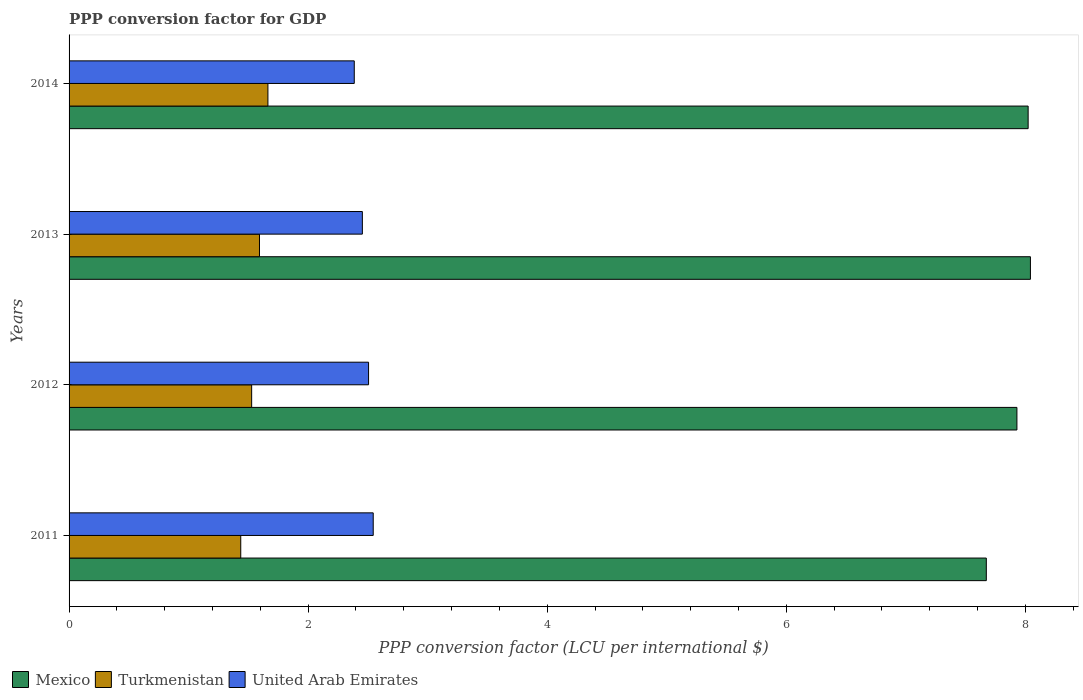How many different coloured bars are there?
Your response must be concise. 3. Are the number of bars on each tick of the Y-axis equal?
Give a very brief answer. Yes. How many bars are there on the 4th tick from the top?
Give a very brief answer. 3. What is the PPP conversion factor for GDP in Turkmenistan in 2012?
Provide a short and direct response. 1.53. Across all years, what is the maximum PPP conversion factor for GDP in Turkmenistan?
Provide a short and direct response. 1.66. Across all years, what is the minimum PPP conversion factor for GDP in United Arab Emirates?
Keep it short and to the point. 2.39. In which year was the PPP conversion factor for GDP in Turkmenistan minimum?
Make the answer very short. 2011. What is the total PPP conversion factor for GDP in Mexico in the graph?
Your response must be concise. 31.67. What is the difference between the PPP conversion factor for GDP in Mexico in 2012 and that in 2014?
Offer a terse response. -0.09. What is the difference between the PPP conversion factor for GDP in Turkmenistan in 2011 and the PPP conversion factor for GDP in Mexico in 2012?
Your response must be concise. -6.49. What is the average PPP conversion factor for GDP in United Arab Emirates per year?
Provide a succinct answer. 2.47. In the year 2013, what is the difference between the PPP conversion factor for GDP in Mexico and PPP conversion factor for GDP in Turkmenistan?
Give a very brief answer. 6.45. In how many years, is the PPP conversion factor for GDP in United Arab Emirates greater than 2 LCU?
Your answer should be very brief. 4. What is the ratio of the PPP conversion factor for GDP in United Arab Emirates in 2011 to that in 2014?
Keep it short and to the point. 1.07. What is the difference between the highest and the second highest PPP conversion factor for GDP in Mexico?
Your answer should be compact. 0.02. What is the difference between the highest and the lowest PPP conversion factor for GDP in United Arab Emirates?
Your answer should be very brief. 0.16. In how many years, is the PPP conversion factor for GDP in United Arab Emirates greater than the average PPP conversion factor for GDP in United Arab Emirates taken over all years?
Provide a succinct answer. 2. What does the 1st bar from the top in 2014 represents?
Keep it short and to the point. United Arab Emirates. What does the 1st bar from the bottom in 2013 represents?
Your answer should be compact. Mexico. How many bars are there?
Provide a succinct answer. 12. How many years are there in the graph?
Ensure brevity in your answer.  4. Are the values on the major ticks of X-axis written in scientific E-notation?
Your response must be concise. No. Does the graph contain any zero values?
Offer a terse response. No. Does the graph contain grids?
Make the answer very short. No. Where does the legend appear in the graph?
Your answer should be compact. Bottom left. How many legend labels are there?
Provide a succinct answer. 3. What is the title of the graph?
Provide a succinct answer. PPP conversion factor for GDP. What is the label or title of the X-axis?
Your answer should be very brief. PPP conversion factor (LCU per international $). What is the PPP conversion factor (LCU per international $) in Mexico in 2011?
Make the answer very short. 7.67. What is the PPP conversion factor (LCU per international $) of Turkmenistan in 2011?
Provide a succinct answer. 1.44. What is the PPP conversion factor (LCU per international $) in United Arab Emirates in 2011?
Provide a succinct answer. 2.54. What is the PPP conversion factor (LCU per international $) of Mexico in 2012?
Provide a short and direct response. 7.93. What is the PPP conversion factor (LCU per international $) in Turkmenistan in 2012?
Give a very brief answer. 1.53. What is the PPP conversion factor (LCU per international $) of United Arab Emirates in 2012?
Provide a short and direct response. 2.51. What is the PPP conversion factor (LCU per international $) of Mexico in 2013?
Keep it short and to the point. 8.04. What is the PPP conversion factor (LCU per international $) in Turkmenistan in 2013?
Your answer should be very brief. 1.59. What is the PPP conversion factor (LCU per international $) of United Arab Emirates in 2013?
Your response must be concise. 2.45. What is the PPP conversion factor (LCU per international $) in Mexico in 2014?
Give a very brief answer. 8.02. What is the PPP conversion factor (LCU per international $) in Turkmenistan in 2014?
Your answer should be very brief. 1.66. What is the PPP conversion factor (LCU per international $) of United Arab Emirates in 2014?
Provide a short and direct response. 2.39. Across all years, what is the maximum PPP conversion factor (LCU per international $) in Mexico?
Keep it short and to the point. 8.04. Across all years, what is the maximum PPP conversion factor (LCU per international $) in Turkmenistan?
Your answer should be very brief. 1.66. Across all years, what is the maximum PPP conversion factor (LCU per international $) of United Arab Emirates?
Offer a terse response. 2.54. Across all years, what is the minimum PPP conversion factor (LCU per international $) in Mexico?
Ensure brevity in your answer.  7.67. Across all years, what is the minimum PPP conversion factor (LCU per international $) of Turkmenistan?
Provide a short and direct response. 1.44. Across all years, what is the minimum PPP conversion factor (LCU per international $) in United Arab Emirates?
Your answer should be compact. 2.39. What is the total PPP conversion factor (LCU per international $) in Mexico in the graph?
Your response must be concise. 31.67. What is the total PPP conversion factor (LCU per international $) of Turkmenistan in the graph?
Keep it short and to the point. 6.22. What is the total PPP conversion factor (LCU per international $) of United Arab Emirates in the graph?
Your answer should be very brief. 9.89. What is the difference between the PPP conversion factor (LCU per international $) of Mexico in 2011 and that in 2012?
Provide a short and direct response. -0.26. What is the difference between the PPP conversion factor (LCU per international $) in Turkmenistan in 2011 and that in 2012?
Your response must be concise. -0.09. What is the difference between the PPP conversion factor (LCU per international $) in United Arab Emirates in 2011 and that in 2012?
Give a very brief answer. 0.04. What is the difference between the PPP conversion factor (LCU per international $) of Mexico in 2011 and that in 2013?
Keep it short and to the point. -0.37. What is the difference between the PPP conversion factor (LCU per international $) in Turkmenistan in 2011 and that in 2013?
Give a very brief answer. -0.16. What is the difference between the PPP conversion factor (LCU per international $) in United Arab Emirates in 2011 and that in 2013?
Your answer should be very brief. 0.09. What is the difference between the PPP conversion factor (LCU per international $) in Mexico in 2011 and that in 2014?
Your answer should be very brief. -0.35. What is the difference between the PPP conversion factor (LCU per international $) of Turkmenistan in 2011 and that in 2014?
Give a very brief answer. -0.23. What is the difference between the PPP conversion factor (LCU per international $) in United Arab Emirates in 2011 and that in 2014?
Keep it short and to the point. 0.16. What is the difference between the PPP conversion factor (LCU per international $) of Mexico in 2012 and that in 2013?
Ensure brevity in your answer.  -0.11. What is the difference between the PPP conversion factor (LCU per international $) in Turkmenistan in 2012 and that in 2013?
Provide a short and direct response. -0.07. What is the difference between the PPP conversion factor (LCU per international $) of United Arab Emirates in 2012 and that in 2013?
Give a very brief answer. 0.05. What is the difference between the PPP conversion factor (LCU per international $) in Mexico in 2012 and that in 2014?
Your answer should be compact. -0.09. What is the difference between the PPP conversion factor (LCU per international $) in Turkmenistan in 2012 and that in 2014?
Your answer should be compact. -0.14. What is the difference between the PPP conversion factor (LCU per international $) of United Arab Emirates in 2012 and that in 2014?
Your response must be concise. 0.12. What is the difference between the PPP conversion factor (LCU per international $) in Mexico in 2013 and that in 2014?
Give a very brief answer. 0.02. What is the difference between the PPP conversion factor (LCU per international $) of Turkmenistan in 2013 and that in 2014?
Give a very brief answer. -0.07. What is the difference between the PPP conversion factor (LCU per international $) of United Arab Emirates in 2013 and that in 2014?
Your answer should be very brief. 0.07. What is the difference between the PPP conversion factor (LCU per international $) in Mexico in 2011 and the PPP conversion factor (LCU per international $) in Turkmenistan in 2012?
Your answer should be compact. 6.15. What is the difference between the PPP conversion factor (LCU per international $) in Mexico in 2011 and the PPP conversion factor (LCU per international $) in United Arab Emirates in 2012?
Your response must be concise. 5.17. What is the difference between the PPP conversion factor (LCU per international $) in Turkmenistan in 2011 and the PPP conversion factor (LCU per international $) in United Arab Emirates in 2012?
Give a very brief answer. -1.07. What is the difference between the PPP conversion factor (LCU per international $) of Mexico in 2011 and the PPP conversion factor (LCU per international $) of Turkmenistan in 2013?
Your answer should be very brief. 6.08. What is the difference between the PPP conversion factor (LCU per international $) of Mexico in 2011 and the PPP conversion factor (LCU per international $) of United Arab Emirates in 2013?
Give a very brief answer. 5.22. What is the difference between the PPP conversion factor (LCU per international $) of Turkmenistan in 2011 and the PPP conversion factor (LCU per international $) of United Arab Emirates in 2013?
Your response must be concise. -1.02. What is the difference between the PPP conversion factor (LCU per international $) of Mexico in 2011 and the PPP conversion factor (LCU per international $) of Turkmenistan in 2014?
Your response must be concise. 6.01. What is the difference between the PPP conversion factor (LCU per international $) of Mexico in 2011 and the PPP conversion factor (LCU per international $) of United Arab Emirates in 2014?
Your response must be concise. 5.29. What is the difference between the PPP conversion factor (LCU per international $) of Turkmenistan in 2011 and the PPP conversion factor (LCU per international $) of United Arab Emirates in 2014?
Your response must be concise. -0.95. What is the difference between the PPP conversion factor (LCU per international $) of Mexico in 2012 and the PPP conversion factor (LCU per international $) of Turkmenistan in 2013?
Ensure brevity in your answer.  6.34. What is the difference between the PPP conversion factor (LCU per international $) in Mexico in 2012 and the PPP conversion factor (LCU per international $) in United Arab Emirates in 2013?
Offer a very short reply. 5.48. What is the difference between the PPP conversion factor (LCU per international $) in Turkmenistan in 2012 and the PPP conversion factor (LCU per international $) in United Arab Emirates in 2013?
Give a very brief answer. -0.93. What is the difference between the PPP conversion factor (LCU per international $) in Mexico in 2012 and the PPP conversion factor (LCU per international $) in Turkmenistan in 2014?
Provide a succinct answer. 6.27. What is the difference between the PPP conversion factor (LCU per international $) of Mexico in 2012 and the PPP conversion factor (LCU per international $) of United Arab Emirates in 2014?
Provide a succinct answer. 5.54. What is the difference between the PPP conversion factor (LCU per international $) in Turkmenistan in 2012 and the PPP conversion factor (LCU per international $) in United Arab Emirates in 2014?
Offer a very short reply. -0.86. What is the difference between the PPP conversion factor (LCU per international $) of Mexico in 2013 and the PPP conversion factor (LCU per international $) of Turkmenistan in 2014?
Give a very brief answer. 6.38. What is the difference between the PPP conversion factor (LCU per international $) of Mexico in 2013 and the PPP conversion factor (LCU per international $) of United Arab Emirates in 2014?
Give a very brief answer. 5.66. What is the difference between the PPP conversion factor (LCU per international $) of Turkmenistan in 2013 and the PPP conversion factor (LCU per international $) of United Arab Emirates in 2014?
Offer a very short reply. -0.79. What is the average PPP conversion factor (LCU per international $) in Mexico per year?
Your answer should be compact. 7.92. What is the average PPP conversion factor (LCU per international $) of Turkmenistan per year?
Give a very brief answer. 1.55. What is the average PPP conversion factor (LCU per international $) of United Arab Emirates per year?
Your answer should be compact. 2.47. In the year 2011, what is the difference between the PPP conversion factor (LCU per international $) in Mexico and PPP conversion factor (LCU per international $) in Turkmenistan?
Make the answer very short. 6.24. In the year 2011, what is the difference between the PPP conversion factor (LCU per international $) in Mexico and PPP conversion factor (LCU per international $) in United Arab Emirates?
Offer a very short reply. 5.13. In the year 2011, what is the difference between the PPP conversion factor (LCU per international $) of Turkmenistan and PPP conversion factor (LCU per international $) of United Arab Emirates?
Ensure brevity in your answer.  -1.11. In the year 2012, what is the difference between the PPP conversion factor (LCU per international $) of Mexico and PPP conversion factor (LCU per international $) of Turkmenistan?
Offer a terse response. 6.4. In the year 2012, what is the difference between the PPP conversion factor (LCU per international $) of Mexico and PPP conversion factor (LCU per international $) of United Arab Emirates?
Keep it short and to the point. 5.42. In the year 2012, what is the difference between the PPP conversion factor (LCU per international $) of Turkmenistan and PPP conversion factor (LCU per international $) of United Arab Emirates?
Provide a short and direct response. -0.98. In the year 2013, what is the difference between the PPP conversion factor (LCU per international $) of Mexico and PPP conversion factor (LCU per international $) of Turkmenistan?
Provide a succinct answer. 6.45. In the year 2013, what is the difference between the PPP conversion factor (LCU per international $) in Mexico and PPP conversion factor (LCU per international $) in United Arab Emirates?
Your response must be concise. 5.59. In the year 2013, what is the difference between the PPP conversion factor (LCU per international $) of Turkmenistan and PPP conversion factor (LCU per international $) of United Arab Emirates?
Your answer should be compact. -0.86. In the year 2014, what is the difference between the PPP conversion factor (LCU per international $) in Mexico and PPP conversion factor (LCU per international $) in Turkmenistan?
Keep it short and to the point. 6.36. In the year 2014, what is the difference between the PPP conversion factor (LCU per international $) in Mexico and PPP conversion factor (LCU per international $) in United Arab Emirates?
Keep it short and to the point. 5.64. In the year 2014, what is the difference between the PPP conversion factor (LCU per international $) in Turkmenistan and PPP conversion factor (LCU per international $) in United Arab Emirates?
Make the answer very short. -0.72. What is the ratio of the PPP conversion factor (LCU per international $) of Turkmenistan in 2011 to that in 2012?
Your response must be concise. 0.94. What is the ratio of the PPP conversion factor (LCU per international $) in United Arab Emirates in 2011 to that in 2012?
Offer a terse response. 1.02. What is the ratio of the PPP conversion factor (LCU per international $) in Mexico in 2011 to that in 2013?
Keep it short and to the point. 0.95. What is the ratio of the PPP conversion factor (LCU per international $) of Turkmenistan in 2011 to that in 2013?
Your answer should be very brief. 0.9. What is the ratio of the PPP conversion factor (LCU per international $) in United Arab Emirates in 2011 to that in 2013?
Your answer should be compact. 1.04. What is the ratio of the PPP conversion factor (LCU per international $) in Mexico in 2011 to that in 2014?
Give a very brief answer. 0.96. What is the ratio of the PPP conversion factor (LCU per international $) of Turkmenistan in 2011 to that in 2014?
Offer a terse response. 0.86. What is the ratio of the PPP conversion factor (LCU per international $) of United Arab Emirates in 2011 to that in 2014?
Your answer should be very brief. 1.07. What is the ratio of the PPP conversion factor (LCU per international $) in Mexico in 2012 to that in 2013?
Ensure brevity in your answer.  0.99. What is the ratio of the PPP conversion factor (LCU per international $) in Turkmenistan in 2012 to that in 2013?
Give a very brief answer. 0.96. What is the ratio of the PPP conversion factor (LCU per international $) in United Arab Emirates in 2012 to that in 2013?
Offer a very short reply. 1.02. What is the ratio of the PPP conversion factor (LCU per international $) in Mexico in 2012 to that in 2014?
Keep it short and to the point. 0.99. What is the ratio of the PPP conversion factor (LCU per international $) in Turkmenistan in 2012 to that in 2014?
Ensure brevity in your answer.  0.92. What is the ratio of the PPP conversion factor (LCU per international $) of United Arab Emirates in 2012 to that in 2014?
Your answer should be compact. 1.05. What is the ratio of the PPP conversion factor (LCU per international $) of Mexico in 2013 to that in 2014?
Ensure brevity in your answer.  1. What is the ratio of the PPP conversion factor (LCU per international $) of Turkmenistan in 2013 to that in 2014?
Provide a short and direct response. 0.96. What is the ratio of the PPP conversion factor (LCU per international $) of United Arab Emirates in 2013 to that in 2014?
Ensure brevity in your answer.  1.03. What is the difference between the highest and the second highest PPP conversion factor (LCU per international $) of Mexico?
Provide a succinct answer. 0.02. What is the difference between the highest and the second highest PPP conversion factor (LCU per international $) of Turkmenistan?
Give a very brief answer. 0.07. What is the difference between the highest and the second highest PPP conversion factor (LCU per international $) in United Arab Emirates?
Ensure brevity in your answer.  0.04. What is the difference between the highest and the lowest PPP conversion factor (LCU per international $) in Mexico?
Provide a succinct answer. 0.37. What is the difference between the highest and the lowest PPP conversion factor (LCU per international $) of Turkmenistan?
Give a very brief answer. 0.23. What is the difference between the highest and the lowest PPP conversion factor (LCU per international $) in United Arab Emirates?
Offer a very short reply. 0.16. 